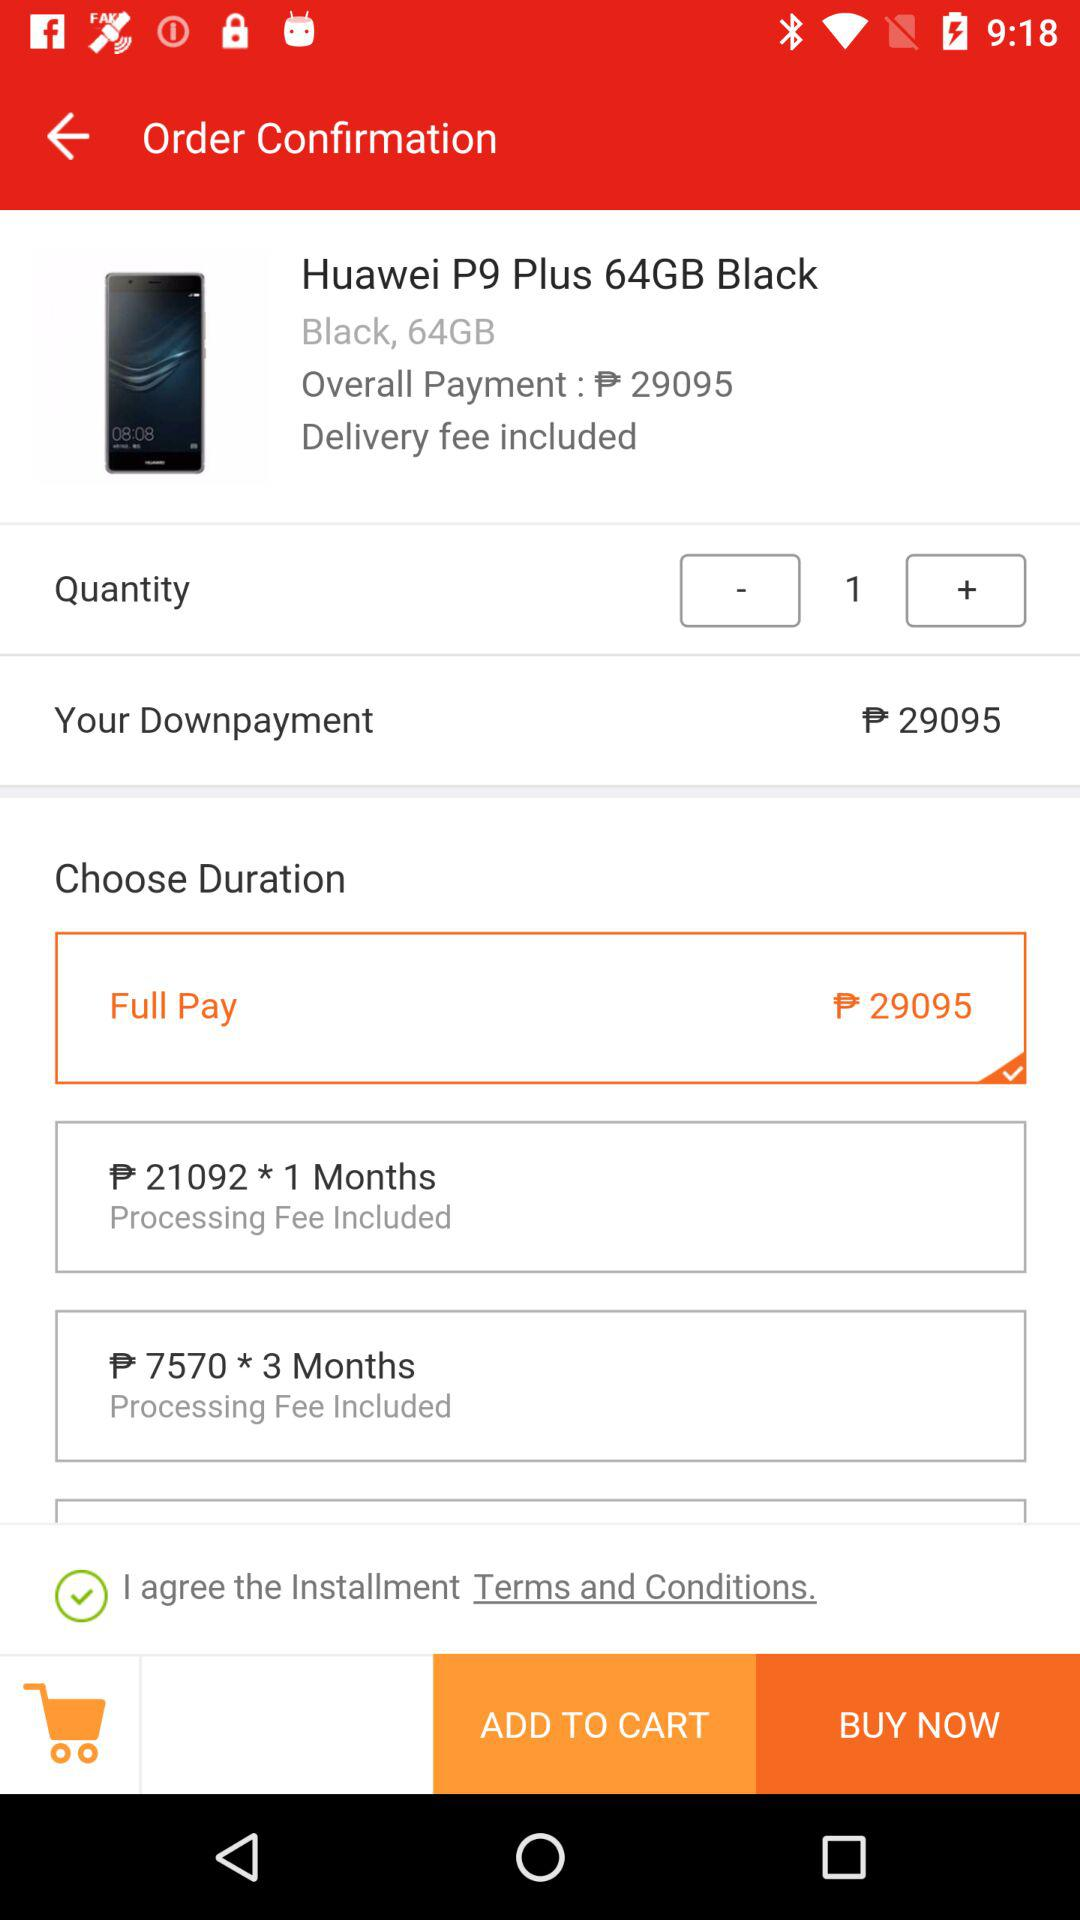What is the price? The price is ₱ 29095. 